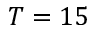<formula> <loc_0><loc_0><loc_500><loc_500>T = 1 5</formula> 